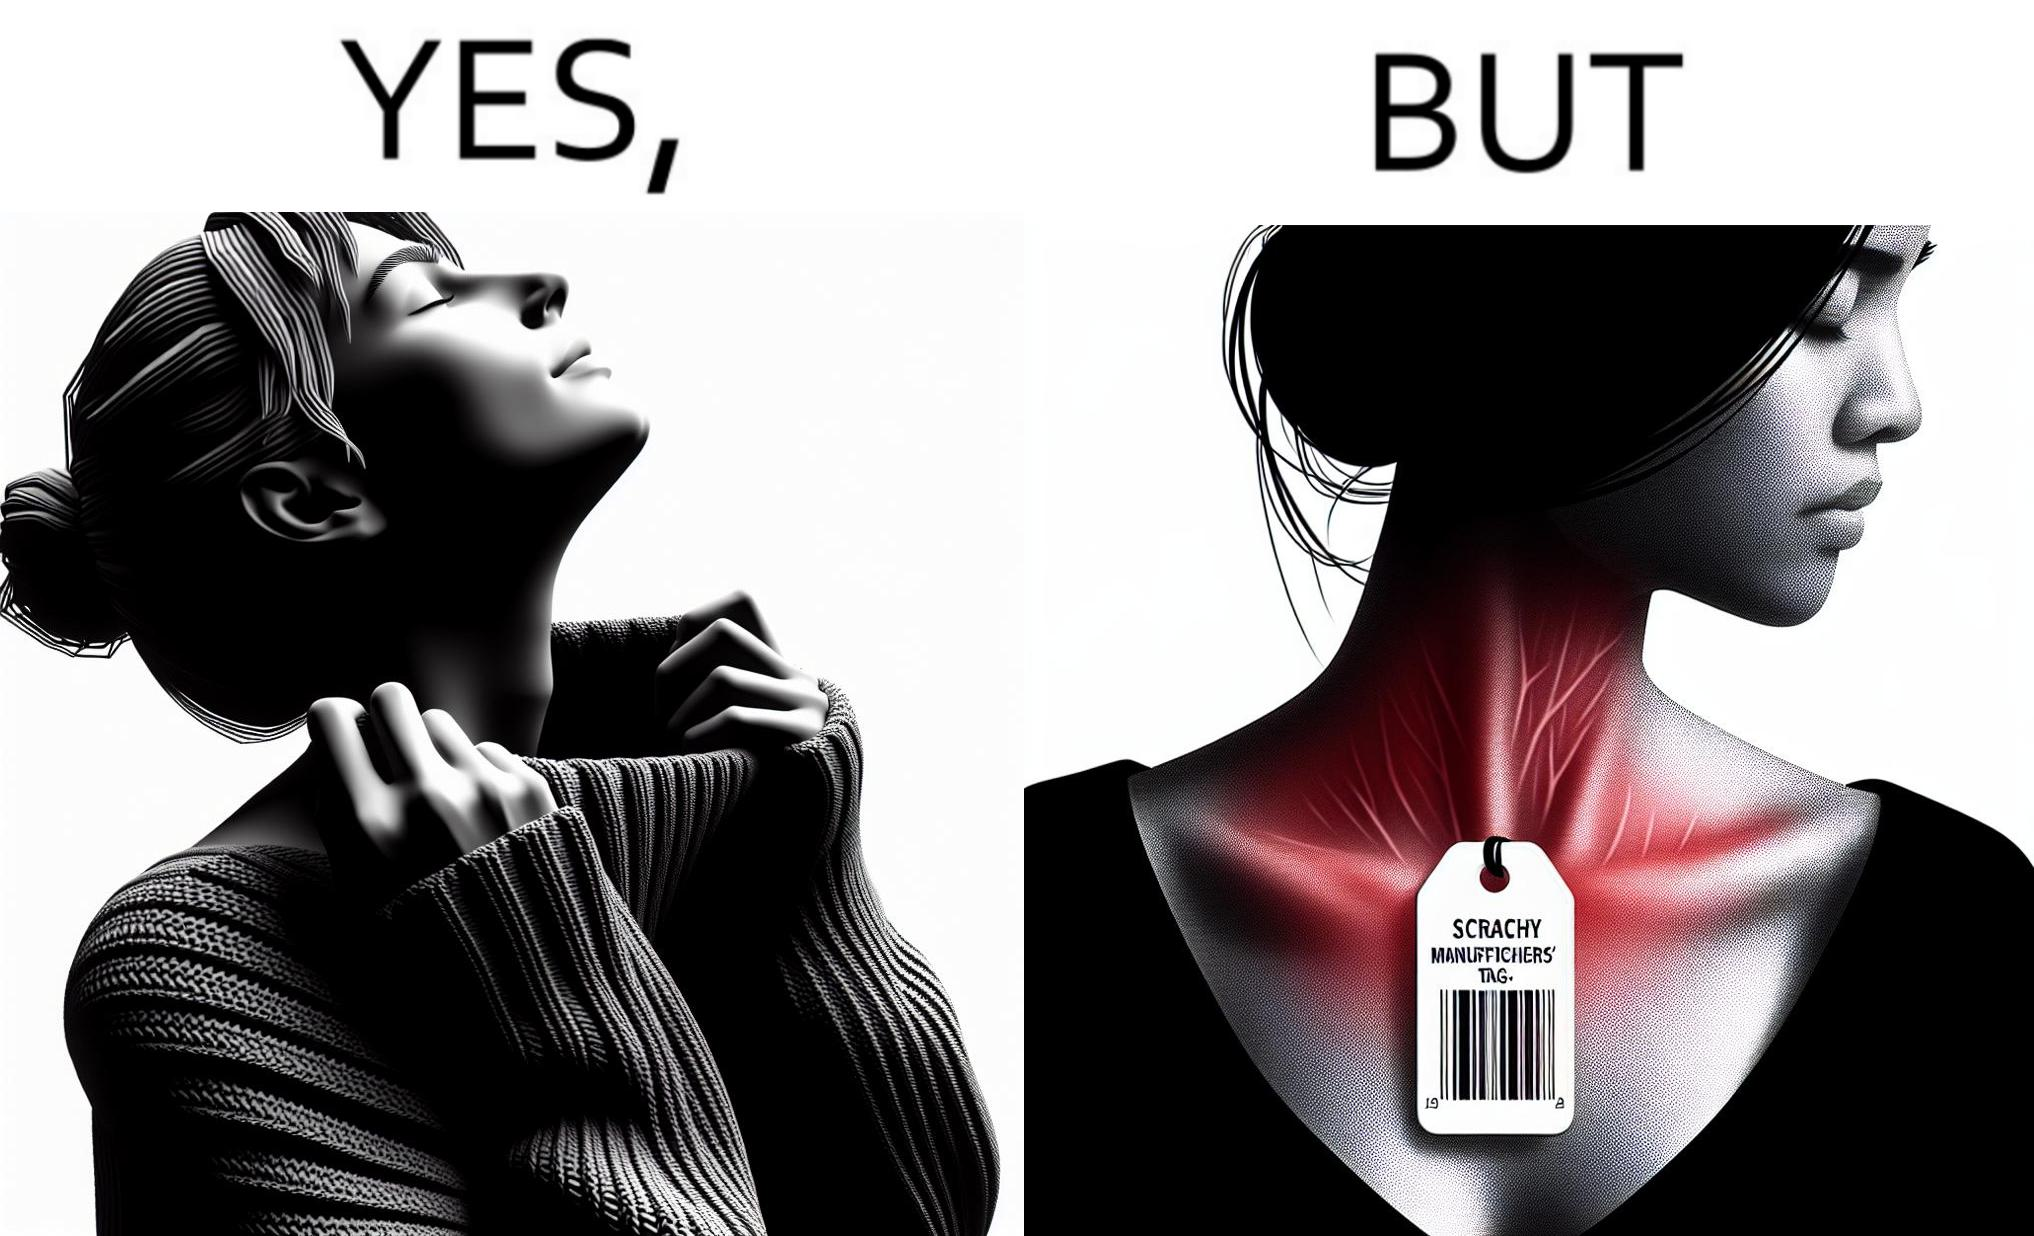Is there satirical content in this image? Yes, this image is satirical. 